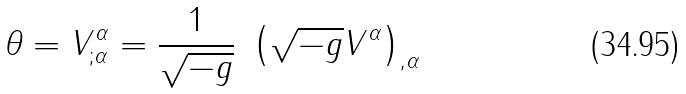Convert formula to latex. <formula><loc_0><loc_0><loc_500><loc_500>\theta = V ^ { \alpha } _ { ; \alpha } = \frac { 1 } { \sqrt { - g } } \ \left ( \sqrt { - g } V ^ { \alpha } \right ) _ { , \alpha }</formula> 